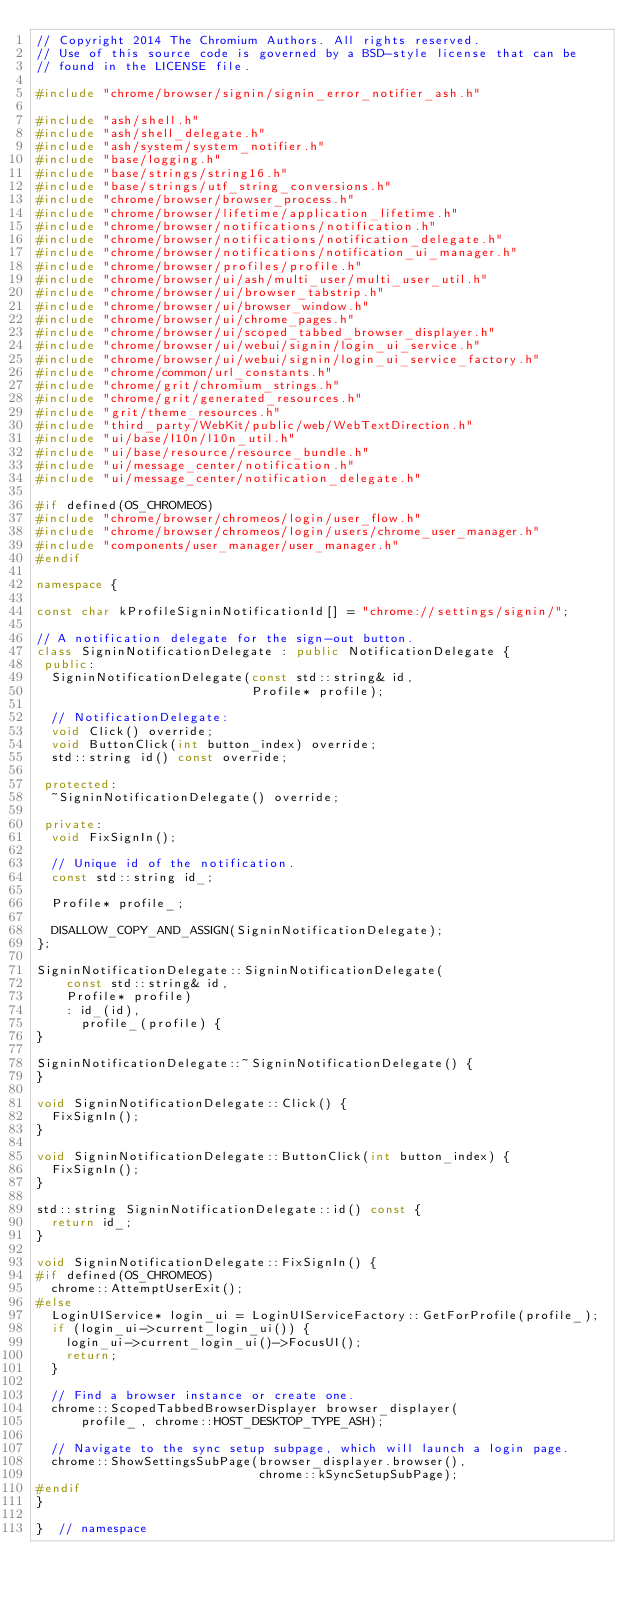Convert code to text. <code><loc_0><loc_0><loc_500><loc_500><_C++_>// Copyright 2014 The Chromium Authors. All rights reserved.
// Use of this source code is governed by a BSD-style license that can be
// found in the LICENSE file.

#include "chrome/browser/signin/signin_error_notifier_ash.h"

#include "ash/shell.h"
#include "ash/shell_delegate.h"
#include "ash/system/system_notifier.h"
#include "base/logging.h"
#include "base/strings/string16.h"
#include "base/strings/utf_string_conversions.h"
#include "chrome/browser/browser_process.h"
#include "chrome/browser/lifetime/application_lifetime.h"
#include "chrome/browser/notifications/notification.h"
#include "chrome/browser/notifications/notification_delegate.h"
#include "chrome/browser/notifications/notification_ui_manager.h"
#include "chrome/browser/profiles/profile.h"
#include "chrome/browser/ui/ash/multi_user/multi_user_util.h"
#include "chrome/browser/ui/browser_tabstrip.h"
#include "chrome/browser/ui/browser_window.h"
#include "chrome/browser/ui/chrome_pages.h"
#include "chrome/browser/ui/scoped_tabbed_browser_displayer.h"
#include "chrome/browser/ui/webui/signin/login_ui_service.h"
#include "chrome/browser/ui/webui/signin/login_ui_service_factory.h"
#include "chrome/common/url_constants.h"
#include "chrome/grit/chromium_strings.h"
#include "chrome/grit/generated_resources.h"
#include "grit/theme_resources.h"
#include "third_party/WebKit/public/web/WebTextDirection.h"
#include "ui/base/l10n/l10n_util.h"
#include "ui/base/resource/resource_bundle.h"
#include "ui/message_center/notification.h"
#include "ui/message_center/notification_delegate.h"

#if defined(OS_CHROMEOS)
#include "chrome/browser/chromeos/login/user_flow.h"
#include "chrome/browser/chromeos/login/users/chrome_user_manager.h"
#include "components/user_manager/user_manager.h"
#endif

namespace {

const char kProfileSigninNotificationId[] = "chrome://settings/signin/";

// A notification delegate for the sign-out button.
class SigninNotificationDelegate : public NotificationDelegate {
 public:
  SigninNotificationDelegate(const std::string& id,
                             Profile* profile);

  // NotificationDelegate:
  void Click() override;
  void ButtonClick(int button_index) override;
  std::string id() const override;

 protected:
  ~SigninNotificationDelegate() override;

 private:
  void FixSignIn();

  // Unique id of the notification.
  const std::string id_;

  Profile* profile_;

  DISALLOW_COPY_AND_ASSIGN(SigninNotificationDelegate);
};

SigninNotificationDelegate::SigninNotificationDelegate(
    const std::string& id,
    Profile* profile)
    : id_(id),
      profile_(profile) {
}

SigninNotificationDelegate::~SigninNotificationDelegate() {
}

void SigninNotificationDelegate::Click() {
  FixSignIn();
}

void SigninNotificationDelegate::ButtonClick(int button_index) {
  FixSignIn();
}

std::string SigninNotificationDelegate::id() const {
  return id_;
}

void SigninNotificationDelegate::FixSignIn() {
#if defined(OS_CHROMEOS)
  chrome::AttemptUserExit();
#else
  LoginUIService* login_ui = LoginUIServiceFactory::GetForProfile(profile_);
  if (login_ui->current_login_ui()) {
    login_ui->current_login_ui()->FocusUI();
    return;
  }

  // Find a browser instance or create one.
  chrome::ScopedTabbedBrowserDisplayer browser_displayer(
      profile_, chrome::HOST_DESKTOP_TYPE_ASH);

  // Navigate to the sync setup subpage, which will launch a login page.
  chrome::ShowSettingsSubPage(browser_displayer.browser(),
                              chrome::kSyncSetupSubPage);
#endif
}

}  // namespace
</code> 